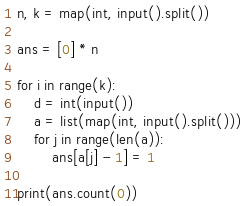<code> <loc_0><loc_0><loc_500><loc_500><_Python_>n, k = map(int, input().split())

ans = [0] * n

for i in range(k):
    d = int(input())
    a = list(map(int, input().split()))
    for j in range(len(a)):
        ans[a[j] - 1] = 1
           
print(ans.count(0))</code> 